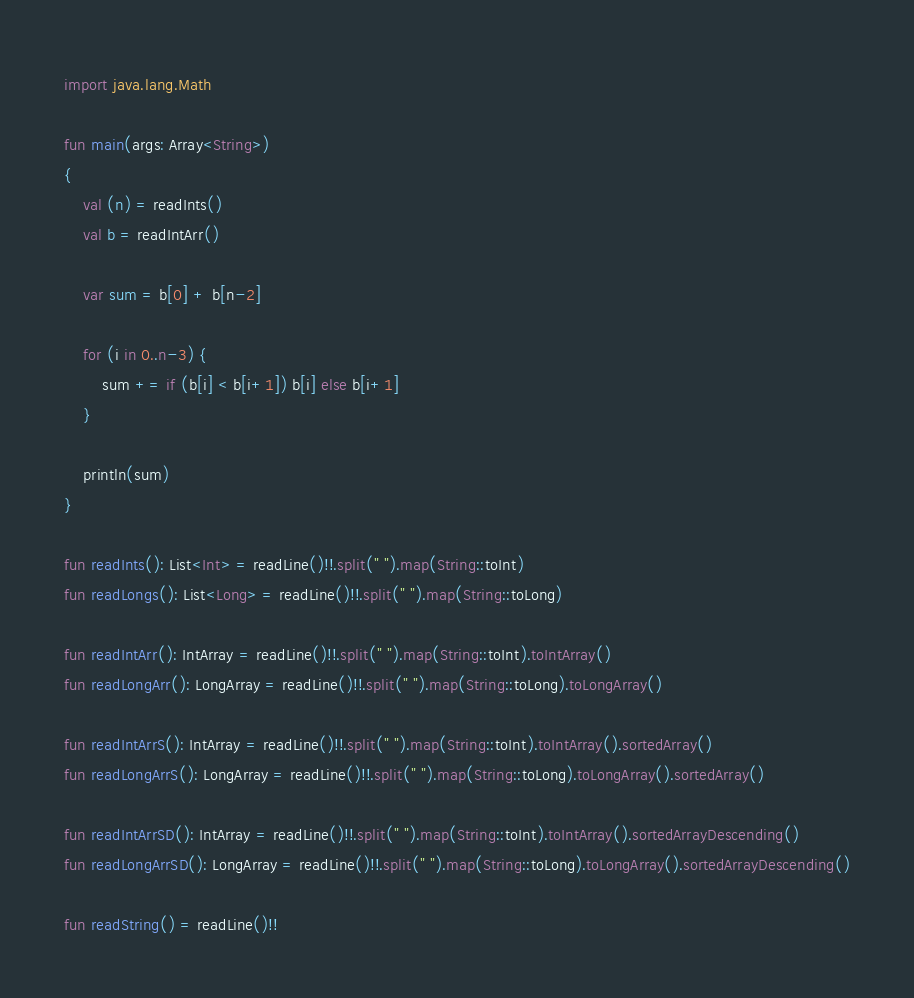<code> <loc_0><loc_0><loc_500><loc_500><_Kotlin_>import java.lang.Math

fun main(args: Array<String>)
{
    val (n) = readInts()
    val b = readIntArr()

    var sum = b[0] + b[n-2]

    for (i in 0..n-3) {
        sum += if (b[i] < b[i+1]) b[i] else b[i+1]
    }

    println(sum)
}

fun readInts(): List<Int> = readLine()!!.split(" ").map(String::toInt)
fun readLongs(): List<Long> = readLine()!!.split(" ").map(String::toLong)

fun readIntArr(): IntArray = readLine()!!.split(" ").map(String::toInt).toIntArray()
fun readLongArr(): LongArray = readLine()!!.split(" ").map(String::toLong).toLongArray()

fun readIntArrS(): IntArray = readLine()!!.split(" ").map(String::toInt).toIntArray().sortedArray()
fun readLongArrS(): LongArray = readLine()!!.split(" ").map(String::toLong).toLongArray().sortedArray()

fun readIntArrSD(): IntArray = readLine()!!.split(" ").map(String::toInt).toIntArray().sortedArrayDescending()
fun readLongArrSD(): LongArray = readLine()!!.split(" ").map(String::toLong).toLongArray().sortedArrayDescending()

fun readString() = readLine()!!
</code> 